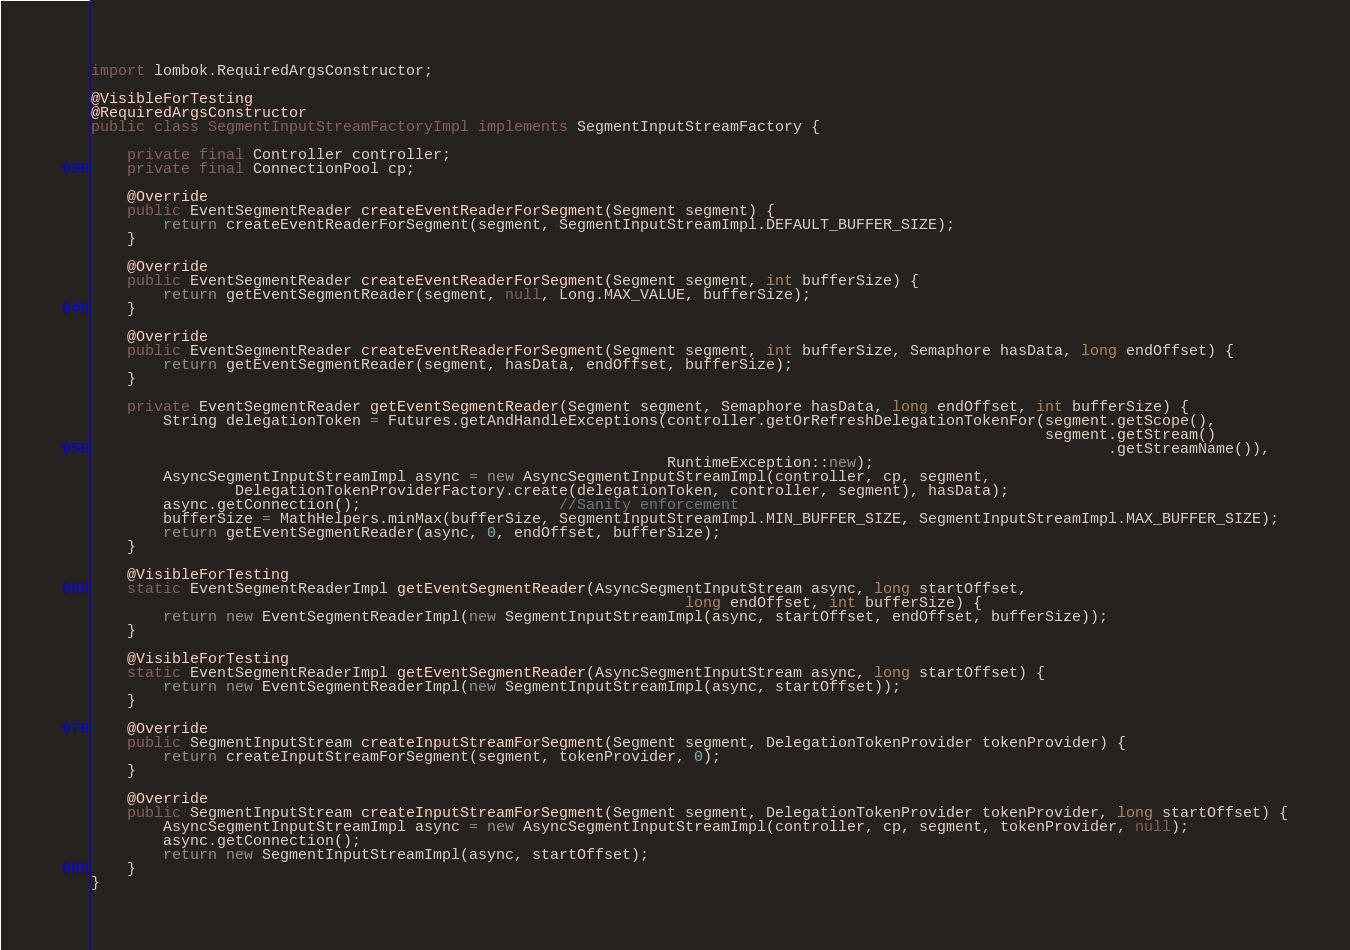Convert code to text. <code><loc_0><loc_0><loc_500><loc_500><_Java_>import lombok.RequiredArgsConstructor;

@VisibleForTesting
@RequiredArgsConstructor
public class SegmentInputStreamFactoryImpl implements SegmentInputStreamFactory {

    private final Controller controller;
    private final ConnectionPool cp;

    @Override
    public EventSegmentReader createEventReaderForSegment(Segment segment) {
        return createEventReaderForSegment(segment, SegmentInputStreamImpl.DEFAULT_BUFFER_SIZE);
    }

    @Override
    public EventSegmentReader createEventReaderForSegment(Segment segment, int bufferSize) {
        return getEventSegmentReader(segment, null, Long.MAX_VALUE, bufferSize);
    }
    
    @Override
    public EventSegmentReader createEventReaderForSegment(Segment segment, int bufferSize, Semaphore hasData, long endOffset) {
        return getEventSegmentReader(segment, hasData, endOffset, bufferSize);
    }

    private EventSegmentReader getEventSegmentReader(Segment segment, Semaphore hasData, long endOffset, int bufferSize) {
        String delegationToken = Futures.getAndHandleExceptions(controller.getOrRefreshDelegationTokenFor(segment.getScope(),
                                                                                                          segment.getStream()
                                                                                                                 .getStreamName()),
                                                                RuntimeException::new);
        AsyncSegmentInputStreamImpl async = new AsyncSegmentInputStreamImpl(controller, cp, segment,
                DelegationTokenProviderFactory.create(delegationToken, controller, segment), hasData);
        async.getConnection();                      //Sanity enforcement
        bufferSize = MathHelpers.minMax(bufferSize, SegmentInputStreamImpl.MIN_BUFFER_SIZE, SegmentInputStreamImpl.MAX_BUFFER_SIZE);
        return getEventSegmentReader(async, 0, endOffset, bufferSize);
    }

    @VisibleForTesting
    static EventSegmentReaderImpl getEventSegmentReader(AsyncSegmentInputStream async, long startOffset,
                                                                  long endOffset, int bufferSize) {
        return new EventSegmentReaderImpl(new SegmentInputStreamImpl(async, startOffset, endOffset, bufferSize));
    }

    @VisibleForTesting
    static EventSegmentReaderImpl getEventSegmentReader(AsyncSegmentInputStream async, long startOffset) {
        return new EventSegmentReaderImpl(new SegmentInputStreamImpl(async, startOffset));
    }

    @Override
    public SegmentInputStream createInputStreamForSegment(Segment segment, DelegationTokenProvider tokenProvider) {
        return createInputStreamForSegment(segment, tokenProvider, 0);
    }

    @Override
    public SegmentInputStream createInputStreamForSegment(Segment segment, DelegationTokenProvider tokenProvider, long startOffset) {
        AsyncSegmentInputStreamImpl async = new AsyncSegmentInputStreamImpl(controller, cp, segment, tokenProvider, null);
        async.getConnection();
        return new SegmentInputStreamImpl(async, startOffset);
    }
}
</code> 